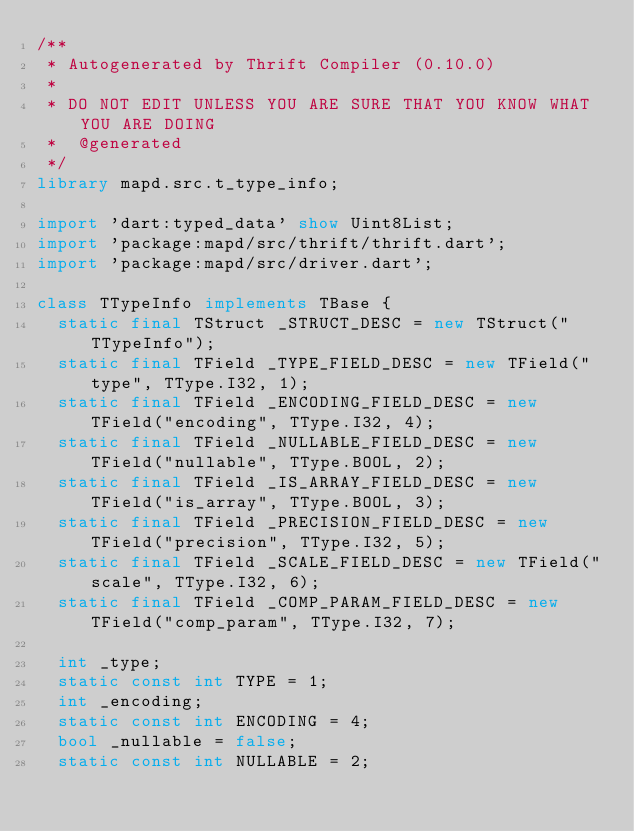<code> <loc_0><loc_0><loc_500><loc_500><_Dart_>/**
 * Autogenerated by Thrift Compiler (0.10.0)
 *
 * DO NOT EDIT UNLESS YOU ARE SURE THAT YOU KNOW WHAT YOU ARE DOING
 *  @generated
 */
library mapd.src.t_type_info;

import 'dart:typed_data' show Uint8List;
import 'package:mapd/src/thrift/thrift.dart';
import 'package:mapd/src/driver.dart';

class TTypeInfo implements TBase {
  static final TStruct _STRUCT_DESC = new TStruct("TTypeInfo");
  static final TField _TYPE_FIELD_DESC = new TField("type", TType.I32, 1);
  static final TField _ENCODING_FIELD_DESC = new TField("encoding", TType.I32, 4);
  static final TField _NULLABLE_FIELD_DESC = new TField("nullable", TType.BOOL, 2);
  static final TField _IS_ARRAY_FIELD_DESC = new TField("is_array", TType.BOOL, 3);
  static final TField _PRECISION_FIELD_DESC = new TField("precision", TType.I32, 5);
  static final TField _SCALE_FIELD_DESC = new TField("scale", TType.I32, 6);
  static final TField _COMP_PARAM_FIELD_DESC = new TField("comp_param", TType.I32, 7);

  int _type;
  static const int TYPE = 1;
  int _encoding;
  static const int ENCODING = 4;
  bool _nullable = false;
  static const int NULLABLE = 2;</code> 